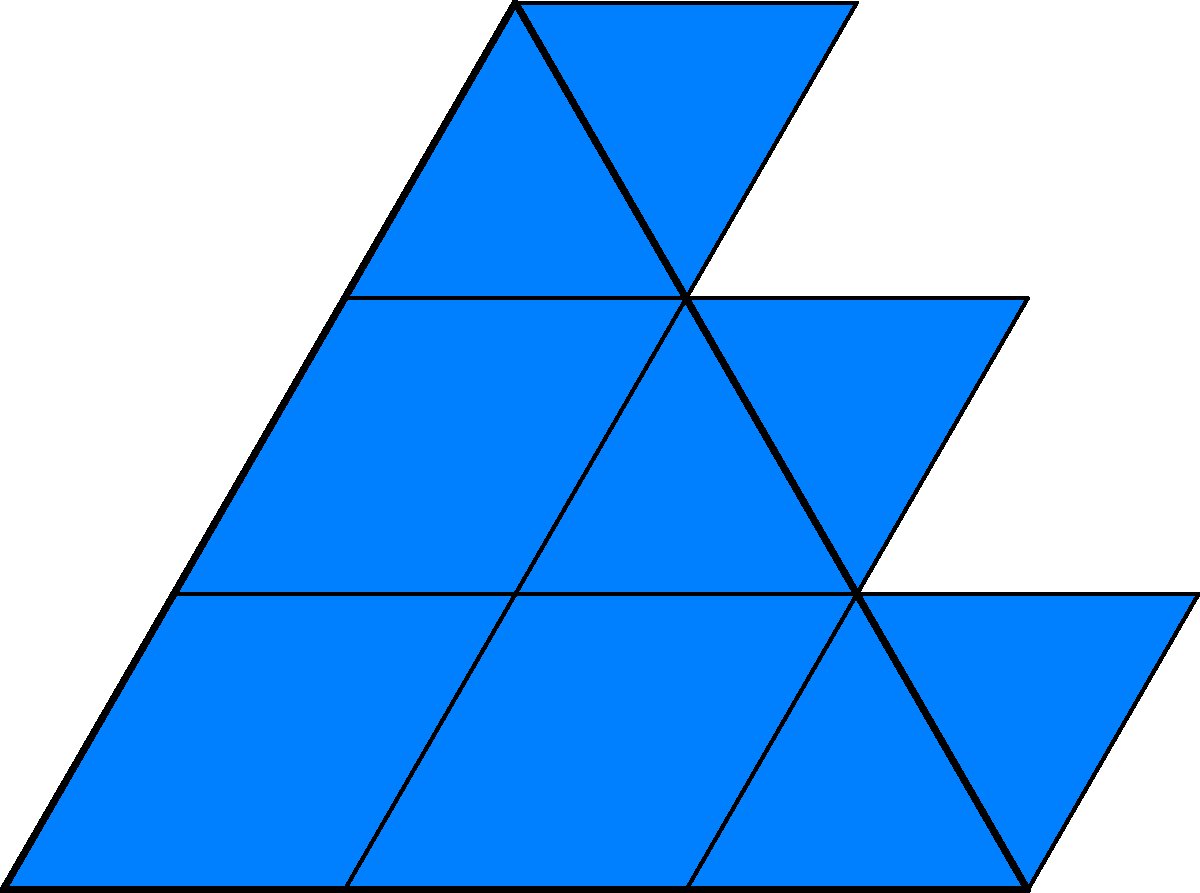What is the minimum number of rhombuses needed to create a seamless scale pattern for King Triton's tail using the tessellation technique shown in the diagram, where the outer triangle represents one full scale? To determine the minimum number of rhombuses needed for one scale:

1. Observe the diagram: The outer triangle represents one full scale.
2. Count the rhombuses within the triangle:
   - Bottom row: 3 rhombuses
   - Middle row: 2 rhombuses
   - Top row: 1 rhombus
3. Sum the rhombuses: 3 + 2 + 1 = 6

Therefore, the minimum number of rhombuses needed to create one complete scale in the pattern is 6.

This tessellation technique allows for a seamless pattern when repeated, as the rhombuses fit together perfectly without gaps or overlaps. Each scale in King Triton's tail would be composed of these 6 rhombuses, creating a realistic and visually appealing fish-like texture.
Answer: 6 rhombuses 